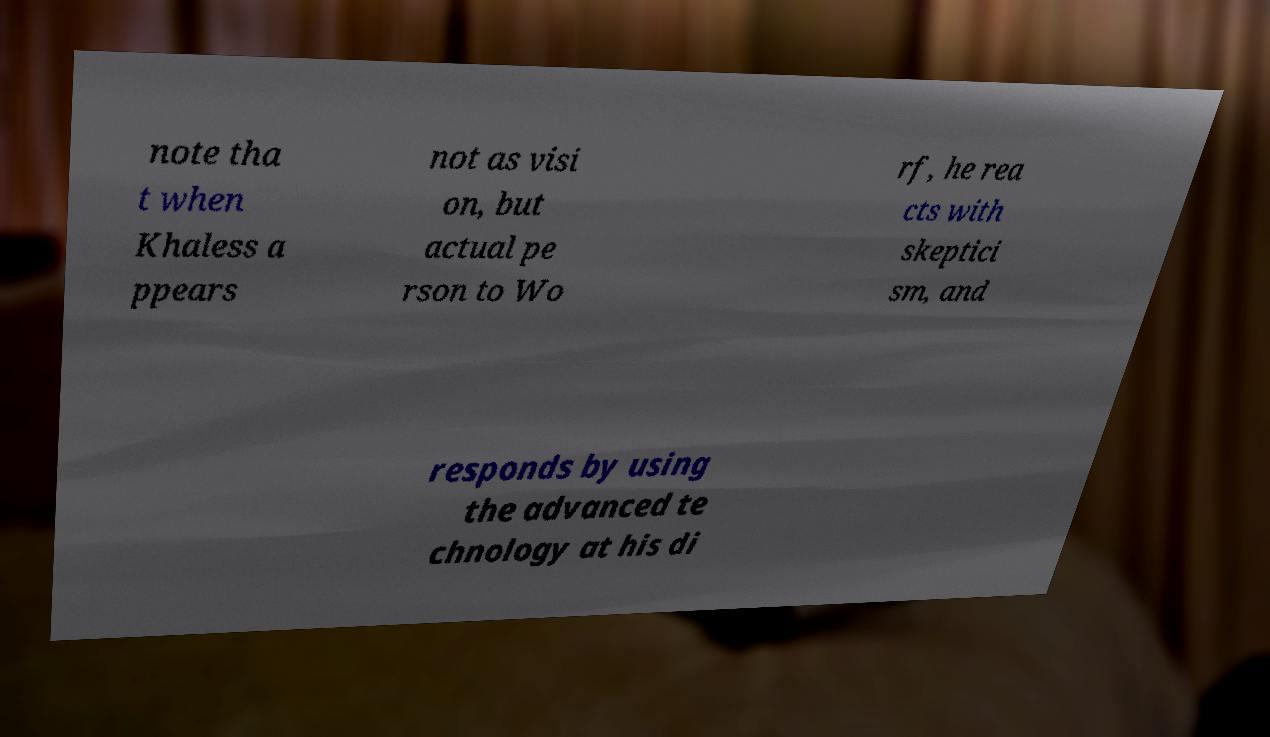Can you read and provide the text displayed in the image?This photo seems to have some interesting text. Can you extract and type it out for me? note tha t when Khaless a ppears not as visi on, but actual pe rson to Wo rf, he rea cts with skeptici sm, and responds by using the advanced te chnology at his di 